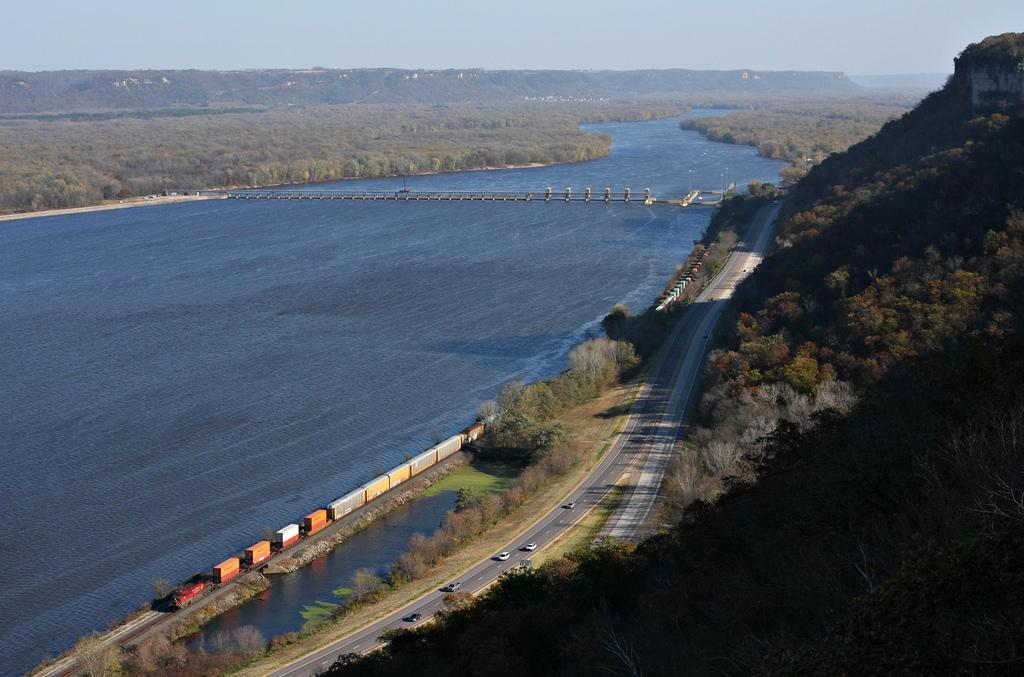What is the main feature of the image? There is a road in the image. What is happening on the road? There are vehicles on the road. Are there any other modes of transportation in the image? Yes, there is a train in the image. What type of natural environment is visible in the image? There is grass, trees, water, and a mountain visible in the image. What part of the sky is visible in the image? The sky is visible in the image. What type of feast is being prepared in the image? There is no indication of a feast being prepared in the image. Can you tell me what toy is being played with in the image? There are no toys visible in the image. 